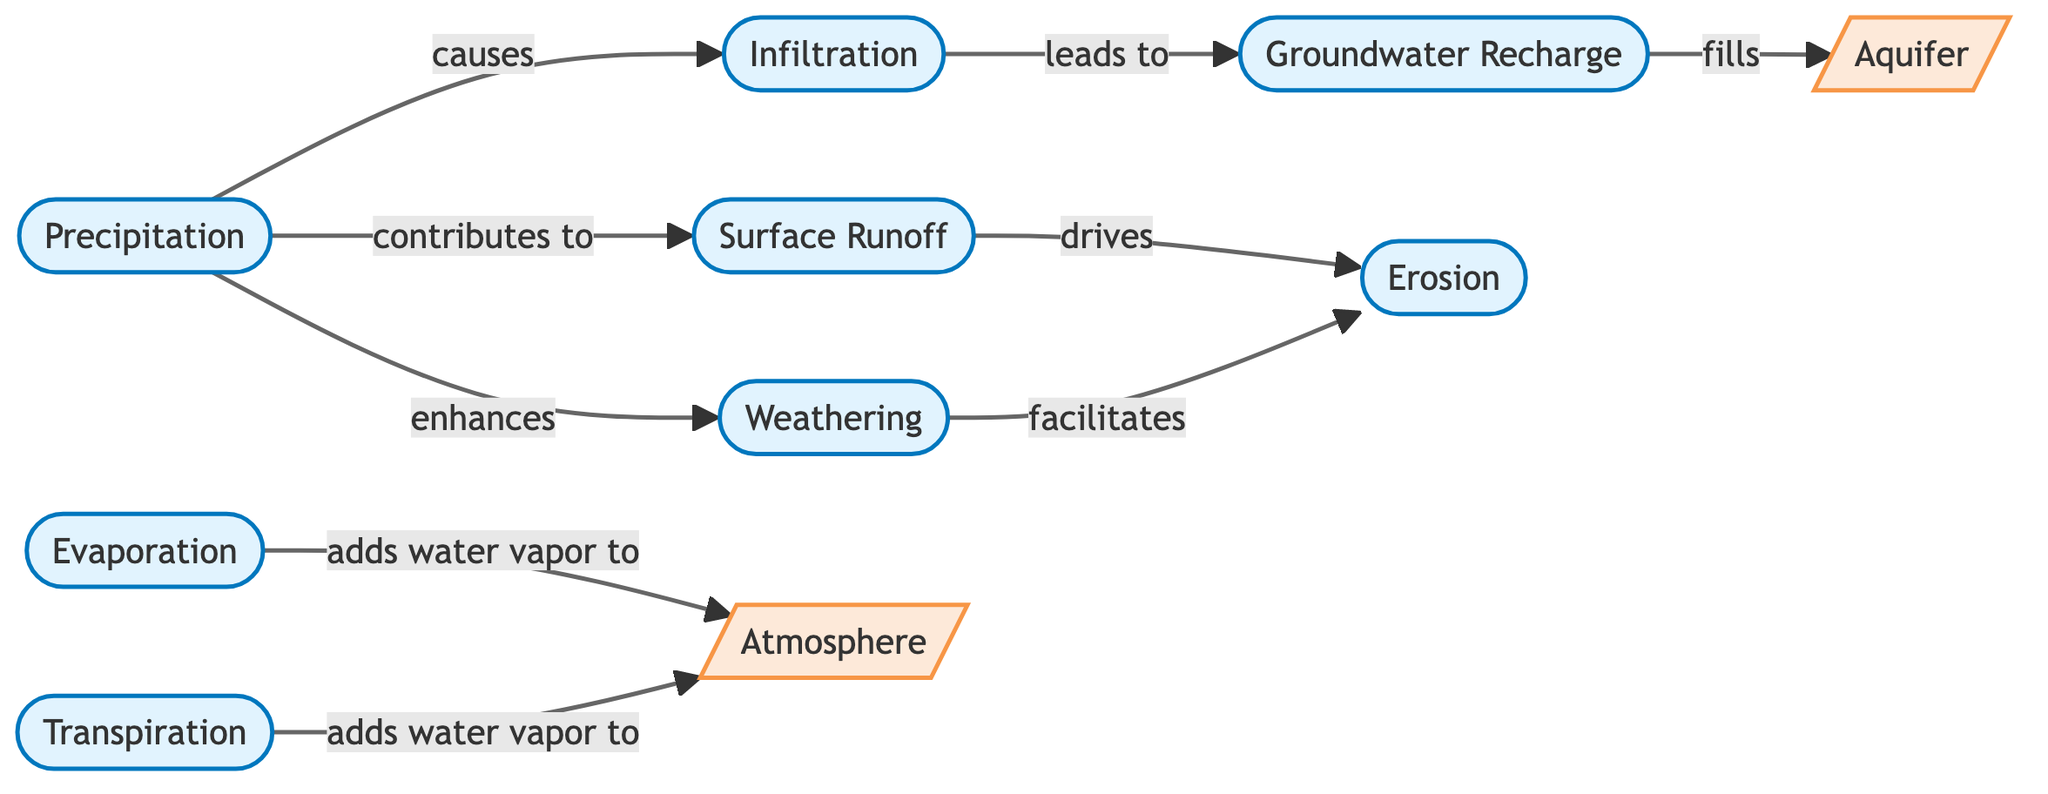What are the main processes involved in the hydrological cycle? The diagram lists several processes: Precipitation, Infiltration, Surface Runoff, Evaporation, Transpiration, Groundwater Recharge, Weathering, and Erosion. These processes interact to form the hydrological cycle as indicated by the nodes in the diagram.
Answer: Precipitation, Infiltration, Surface Runoff, Evaporation, Transpiration, Groundwater Recharge, Weathering, Erosion Which node enhances weathering? According to the diagram, Precipitation has a directed arrow labeled "enhances" pointing towards Weathering, indicating that precipitation contributes positively to the weathering process.
Answer: Precipitation How many nodes are included in the diagram? By counting the nodes listed, we identify a total of 8 nodes: Precipitation, Infiltration, Surface Runoff, Evaporation, Transpiration, Groundwater Recharge, Aquifer, Weathering, and Erosion. This gives a direct count of the components involved in the hydrological cycle.
Answer: 8 What is the relationship between Surface Runoff and Erosion? The diagram specifies that Surface Runoff "drives" Erosion, showing a direct impact of surface runoff on the erosion process within the hydrological cycle. This indicates a causal influence.
Answer: drives Which node leads to groundwater recharge? The diagram shows a directed arrow from Infiltration to Groundwater Recharge labeled "leads to," indicating that the process of infiltration is critical for replenishing groundwater.
Answer: Infiltration Which two nodes add water vapor to the atmosphere? Both Evaporation and Transpiration are shown in the diagram with arrows connecting to the Atmosphere, each labeled "adds water vapor to," reinforcing their roles in contributing moisture to the air.
Answer: Evaporation, Transpiration What geological formation is filled by groundwater recharge? The diagram shows a direct link from Groundwater Recharge to Aquifer, indicating that the processes associated with groundwater recharge are responsible for filling aquifers.
Answer: Aquifer How does weathering facilitate erosion? The relationship is depicted by an arrow from Weathering to Erosion labeled "facilitates," which means that weathering prepares materials, making them easier to be transported by erosion processes.
Answer: facilitates 